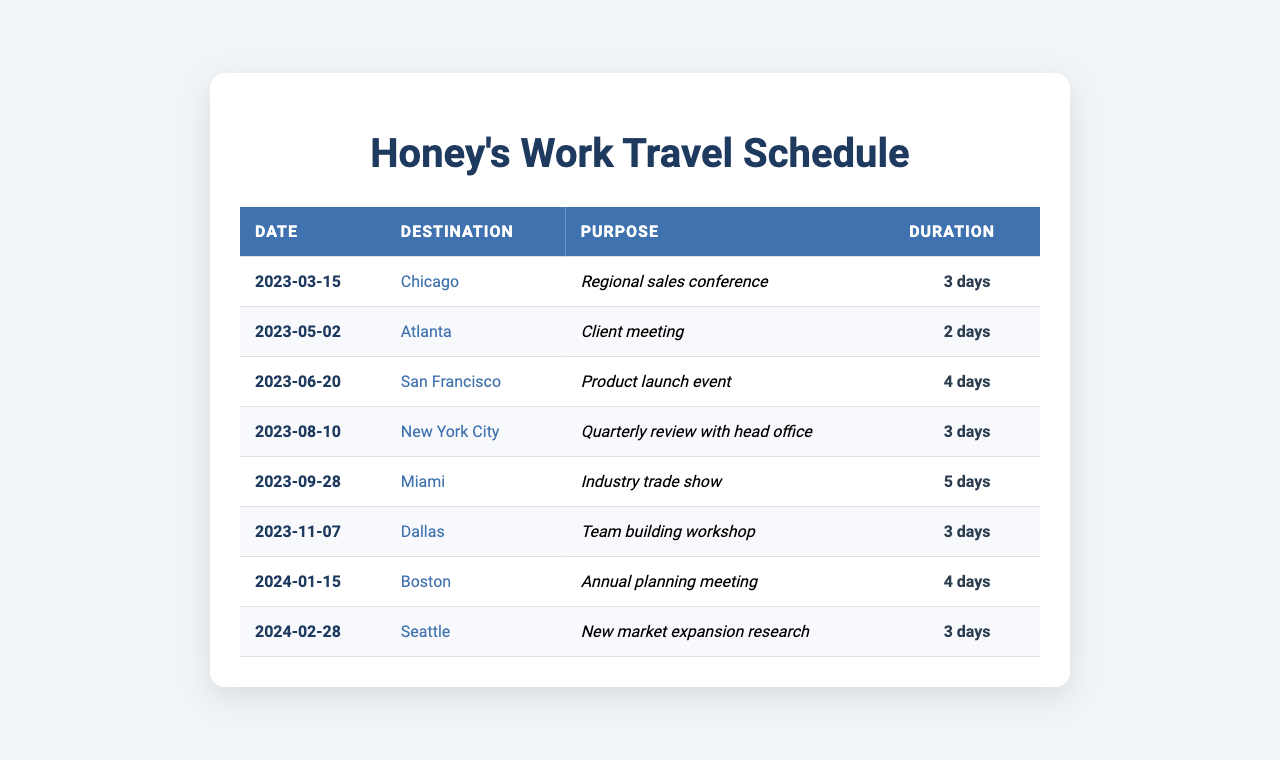What is the reported purpose of the trip to New York City? The table shows that the destination for this trip is New York City, and the reported purpose listed is "Quarterly review with head office."
Answer: Quarterly review with head office How many days did the spouse spend in Miami? According to the table, the duration of the trip to Miami is listed as 5 days.
Answer: 5 days Which destination had the longest duration of travel? Reviewing the duration column, the longest duration is 5 days for the trip to Miami.
Answer: Miami What total number of days did the spouse spend traveling for work in 2023? Adding the durations from all trips in 2023: 3 (Chicago) + 2 (Atlanta) + 4 (San Francisco) + 3 (New York City) + 5 (Miami) totals to 17 days.
Answer: 17 days Was there a trip for a client meeting in 2024? There is no trip listed in 2024 for a client meeting referenced in the table.
Answer: No How many trips were taken for team-building purposes? The table indicates that there is one trip specifically for team-building purposes, which is to Dallas.
Answer: 1 trip What is the average duration of the trips reported? Adding the durations (3 + 2 + 4 + 3 + 5 + 3 + 4 + 3) gives 27 days, divided by 8 trips results in an average duration of 3.375 days.
Answer: 3.375 days Which city was visited for the industry trade show? The table specifies that Miami was the destination for the industry trade show.
Answer: Miami How many trips took place before June 2023? Three trips occurred before June 2023: to Chicago, Atlanta, and San Francisco.
Answer: 3 trips Which trip had the highest number of reported days? The trip with the highest reported duration of 5 days was the trip to Miami for the industry trade show.
Answer: Miami 